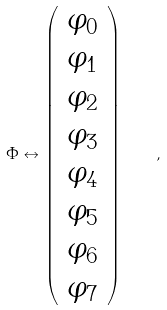Convert formula to latex. <formula><loc_0><loc_0><loc_500><loc_500>\Phi \leftrightarrow \left ( \begin{array} { c } { { \varphi _ { 0 } } } \\ { { \varphi _ { 1 } } } \\ { { \varphi _ { 2 } } } \\ { { \varphi _ { 3 } } } \\ { { \varphi _ { 4 } } } \\ { { \varphi _ { 5 } } } \\ { { \varphi _ { 6 } } } \\ { { \varphi _ { 7 } } } \end{array} \right ) \quad ,</formula> 